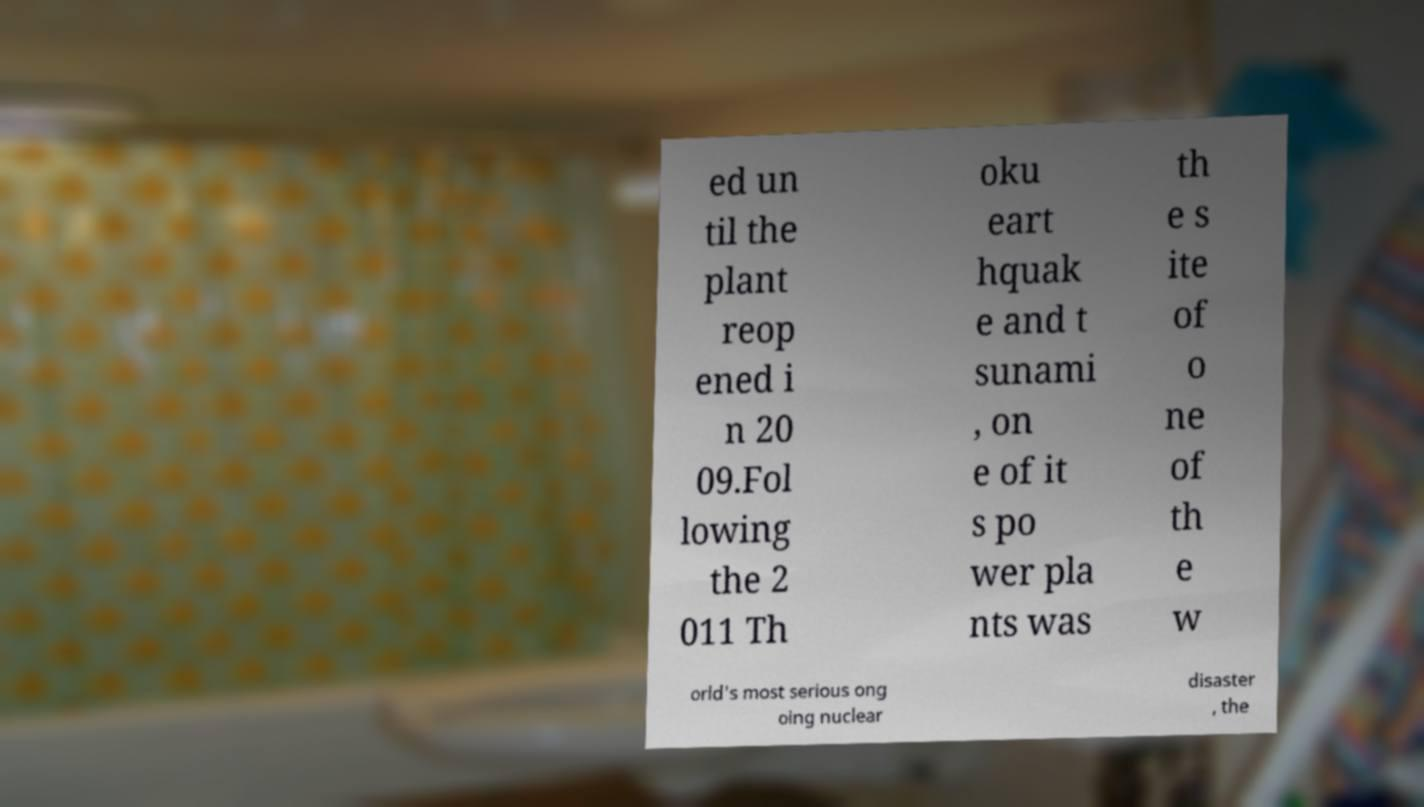For documentation purposes, I need the text within this image transcribed. Could you provide that? ed un til the plant reop ened i n 20 09.Fol lowing the 2 011 Th oku eart hquak e and t sunami , on e of it s po wer pla nts was th e s ite of o ne of th e w orld's most serious ong oing nuclear disaster , the 